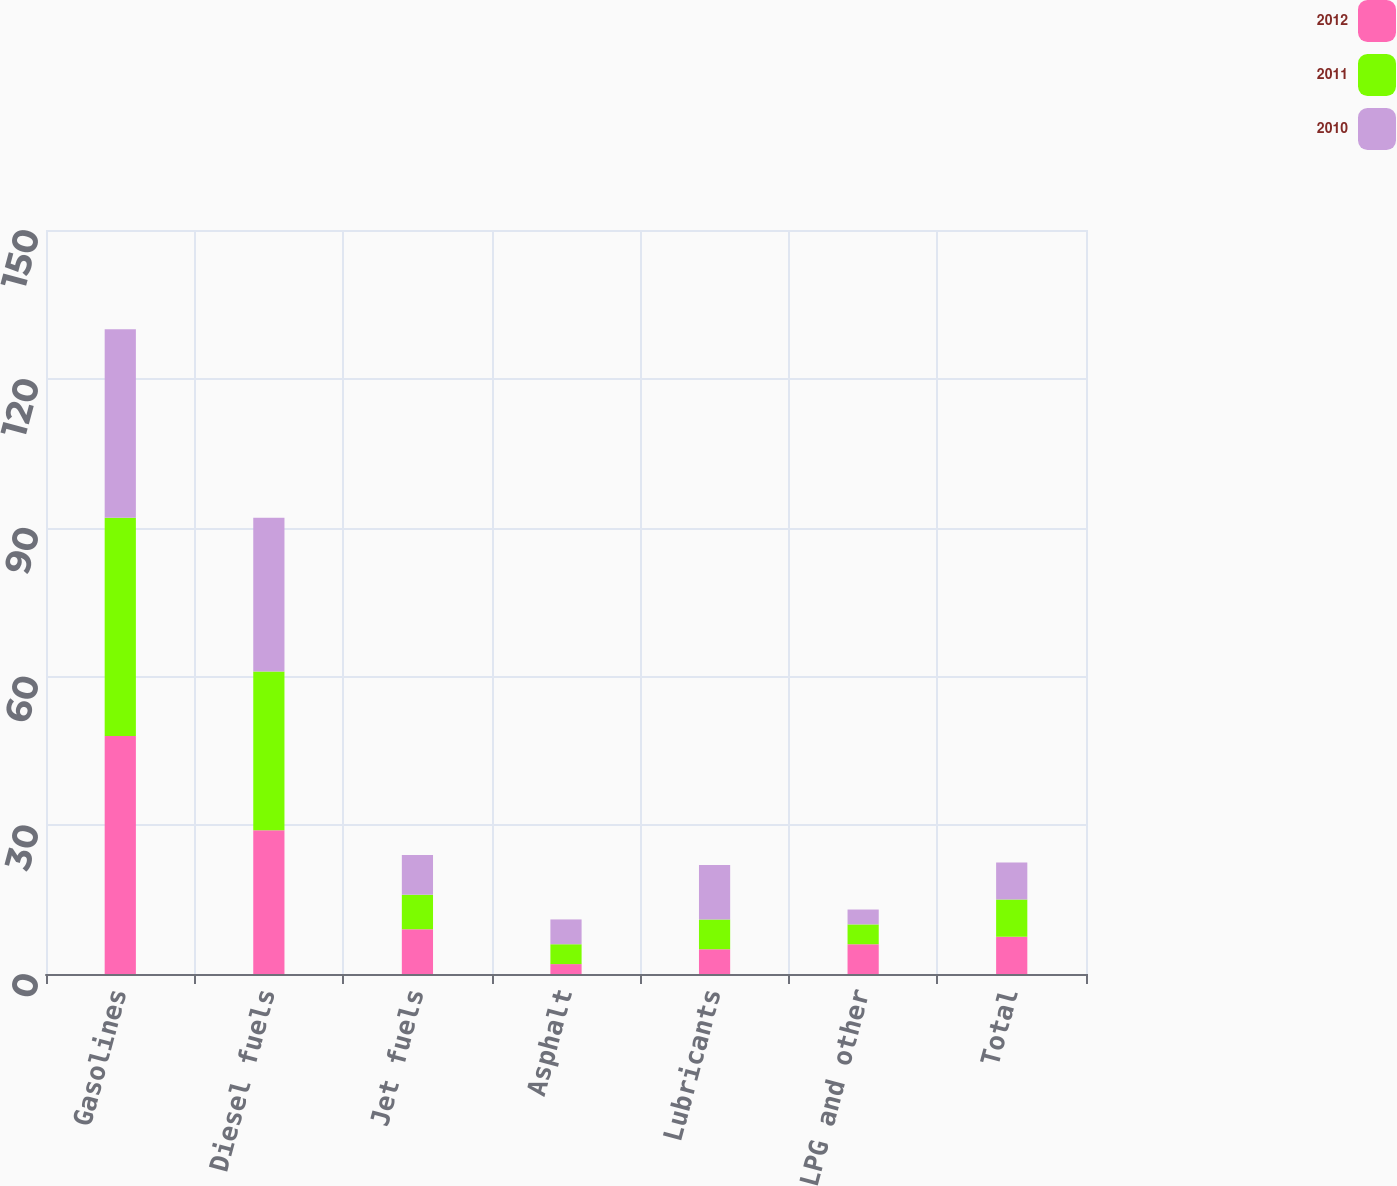<chart> <loc_0><loc_0><loc_500><loc_500><stacked_bar_chart><ecel><fcel>Gasolines<fcel>Diesel fuels<fcel>Jet fuels<fcel>Asphalt<fcel>Lubricants<fcel>LPG and other<fcel>Total<nl><fcel>2012<fcel>48<fcel>29<fcel>9<fcel>2<fcel>5<fcel>6<fcel>7.5<nl><fcel>2011<fcel>44<fcel>32<fcel>7<fcel>4<fcel>6<fcel>4<fcel>7.5<nl><fcel>2010<fcel>38<fcel>31<fcel>8<fcel>5<fcel>11<fcel>3<fcel>7.5<nl></chart> 